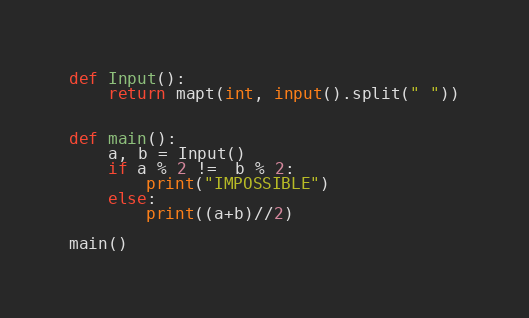<code> <loc_0><loc_0><loc_500><loc_500><_Python_>
def Input():
    return mapt(int, input().split(" "))


def main():
    a, b = Input()
    if a % 2 !=  b % 2:
        print("IMPOSSIBLE")
    else:
        print((a+b)//2)

main()</code> 